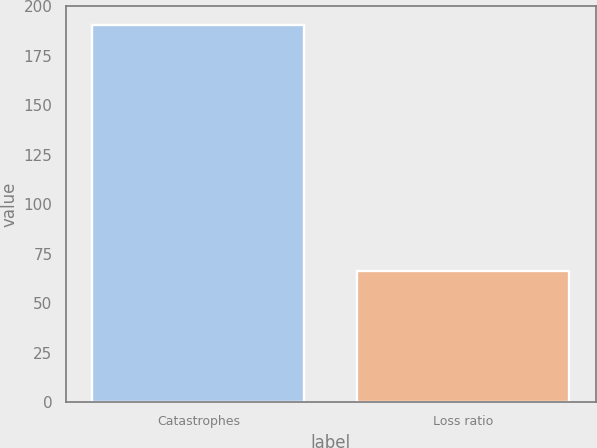Convert chart to OTSL. <chart><loc_0><loc_0><loc_500><loc_500><bar_chart><fcel>Catastrophes<fcel>Loss ratio<nl><fcel>190.6<fcel>66.4<nl></chart> 